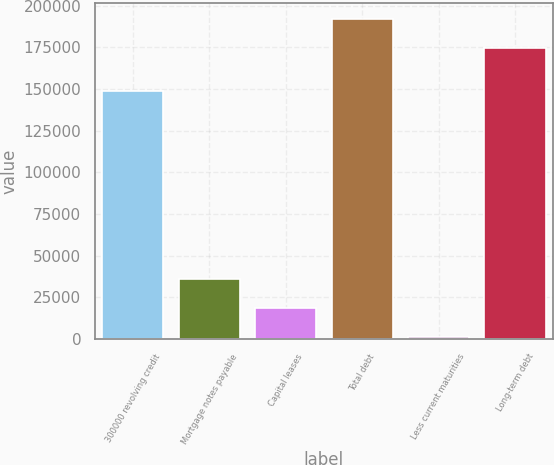Convert chart to OTSL. <chart><loc_0><loc_0><loc_500><loc_500><bar_chart><fcel>300000 revolving credit<fcel>Mortgage notes payable<fcel>Capital leases<fcel>Total debt<fcel>Less current maturities<fcel>Long-term debt<nl><fcel>149000<fcel>35900.2<fcel>18435.6<fcel>192111<fcel>971<fcel>174646<nl></chart> 